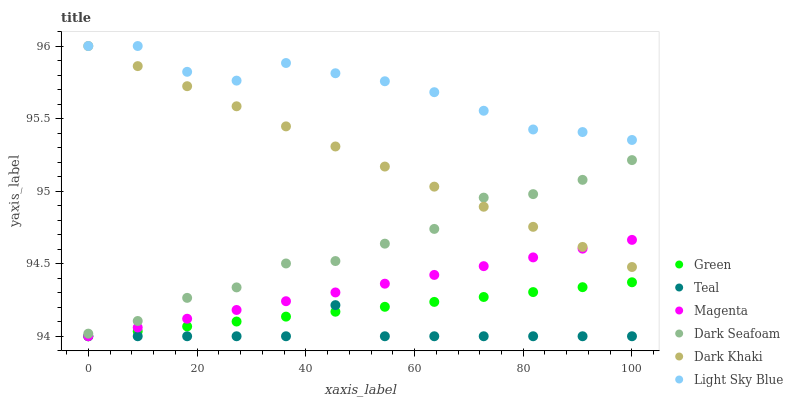Does Teal have the minimum area under the curve?
Answer yes or no. Yes. Does Light Sky Blue have the maximum area under the curve?
Answer yes or no. Yes. Does Dark Seafoam have the minimum area under the curve?
Answer yes or no. No. Does Dark Seafoam have the maximum area under the curve?
Answer yes or no. No. Is Magenta the smoothest?
Answer yes or no. Yes. Is Dark Seafoam the roughest?
Answer yes or no. Yes. Is Light Sky Blue the smoothest?
Answer yes or no. No. Is Light Sky Blue the roughest?
Answer yes or no. No. Does Green have the lowest value?
Answer yes or no. Yes. Does Dark Seafoam have the lowest value?
Answer yes or no. No. Does Light Sky Blue have the highest value?
Answer yes or no. Yes. Does Dark Seafoam have the highest value?
Answer yes or no. No. Is Teal less than Dark Khaki?
Answer yes or no. Yes. Is Light Sky Blue greater than Dark Seafoam?
Answer yes or no. Yes. Does Magenta intersect Dark Khaki?
Answer yes or no. Yes. Is Magenta less than Dark Khaki?
Answer yes or no. No. Is Magenta greater than Dark Khaki?
Answer yes or no. No. Does Teal intersect Dark Khaki?
Answer yes or no. No. 